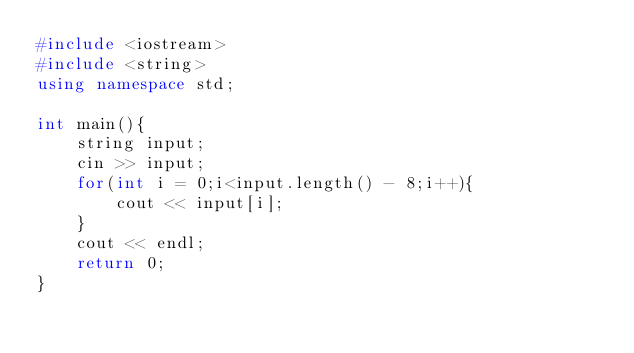<code> <loc_0><loc_0><loc_500><loc_500><_C++_>#include <iostream>
#include <string>
using namespace std;

int main(){
    string input;
    cin >> input;
    for(int i = 0;i<input.length() - 8;i++){
        cout << input[i];
    }
    cout << endl;
    return 0;
}</code> 